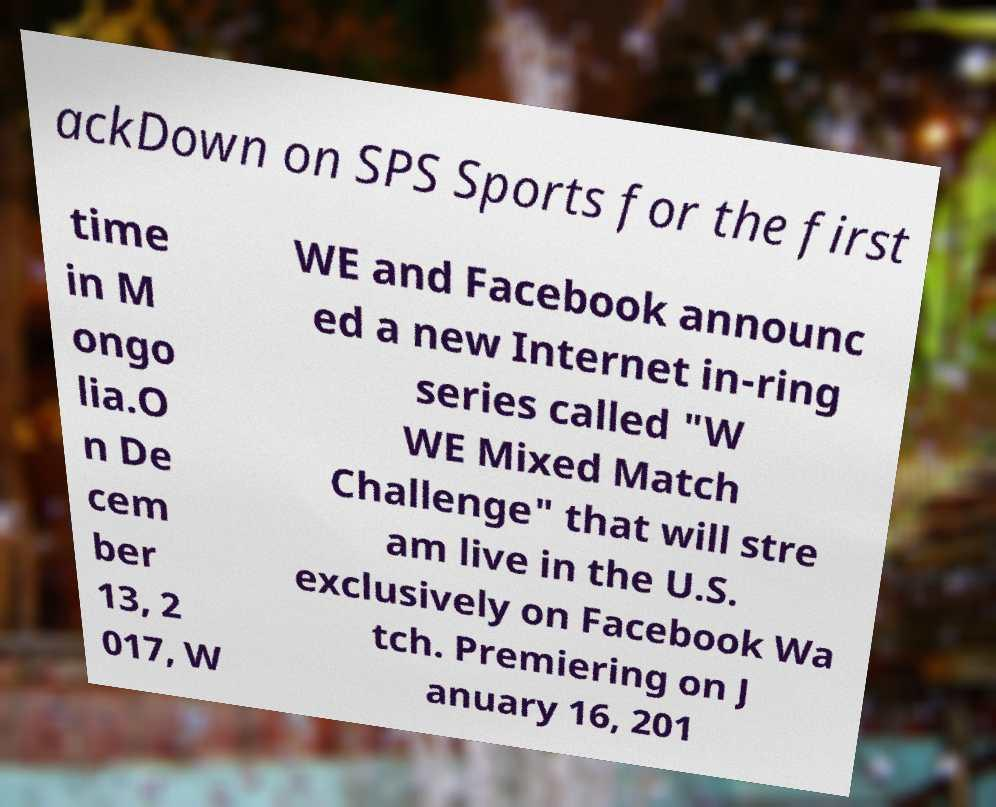What messages or text are displayed in this image? I need them in a readable, typed format. ackDown on SPS Sports for the first time in M ongo lia.O n De cem ber 13, 2 017, W WE and Facebook announc ed a new Internet in-ring series called "W WE Mixed Match Challenge" that will stre am live in the U.S. exclusively on Facebook Wa tch. Premiering on J anuary 16, 201 